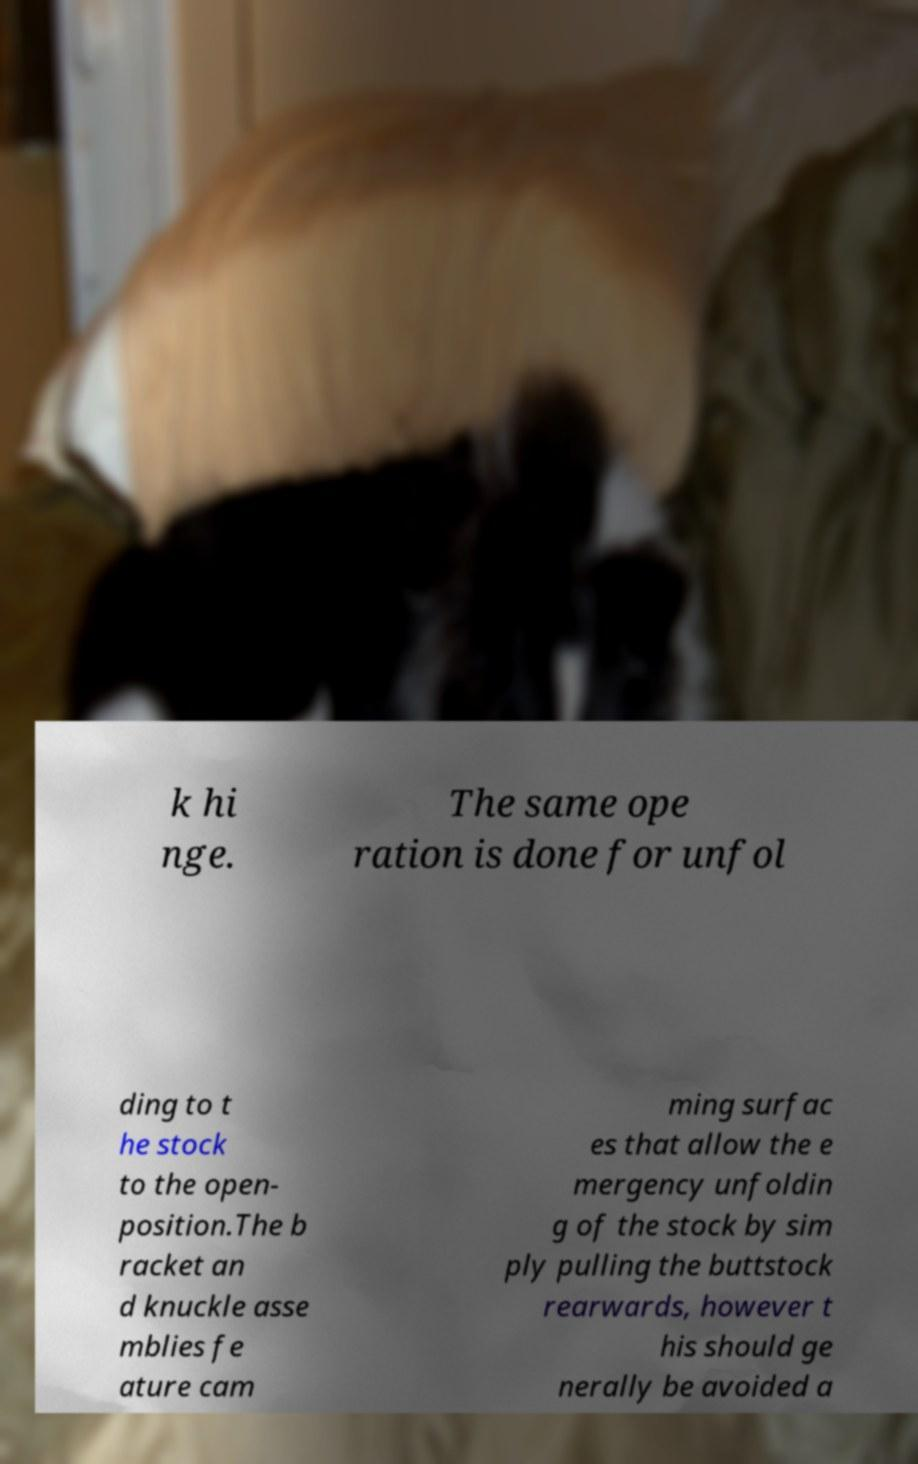Please read and relay the text visible in this image. What does it say? k hi nge. The same ope ration is done for unfol ding to t he stock to the open- position.The b racket an d knuckle asse mblies fe ature cam ming surfac es that allow the e mergency unfoldin g of the stock by sim ply pulling the buttstock rearwards, however t his should ge nerally be avoided a 